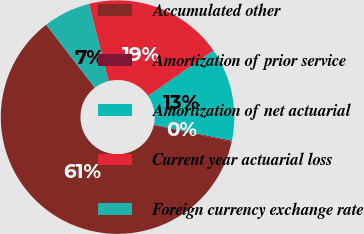<chart> <loc_0><loc_0><loc_500><loc_500><pie_chart><fcel>Accumulated other<fcel>Amortization of prior service<fcel>Amortization of net actuarial<fcel>Current year actuarial loss<fcel>Foreign currency exchange rate<nl><fcel>61.13%<fcel>0.17%<fcel>12.9%<fcel>19.27%<fcel>6.53%<nl></chart> 